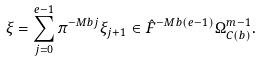<formula> <loc_0><loc_0><loc_500><loc_500>\xi = \sum _ { j = 0 } ^ { e - 1 } \pi ^ { - M b j } \xi _ { j + 1 } \in \hat { F } ^ { - M b ( e - 1 ) } \Omega ^ { m - 1 } _ { C ( b ) } .</formula> 